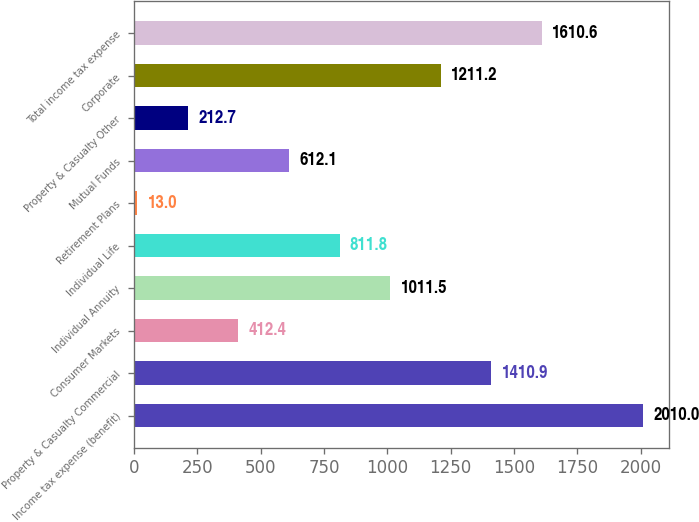Convert chart. <chart><loc_0><loc_0><loc_500><loc_500><bar_chart><fcel>Income tax expense (benefit)<fcel>Property & Casualty Commercial<fcel>Consumer Markets<fcel>Individual Annuity<fcel>Individual Life<fcel>Retirement Plans<fcel>Mutual Funds<fcel>Property & Casualty Other<fcel>Corporate<fcel>Total income tax expense<nl><fcel>2010<fcel>1410.9<fcel>412.4<fcel>1011.5<fcel>811.8<fcel>13<fcel>612.1<fcel>212.7<fcel>1211.2<fcel>1610.6<nl></chart> 